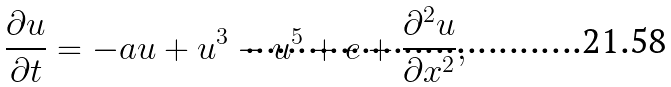Convert formula to latex. <formula><loc_0><loc_0><loc_500><loc_500>\frac { \partial u } { \partial t } = - a u + u ^ { 3 } - u ^ { 5 } + e + \frac { \partial ^ { 2 } u } { \partial x ^ { 2 } } ,</formula> 